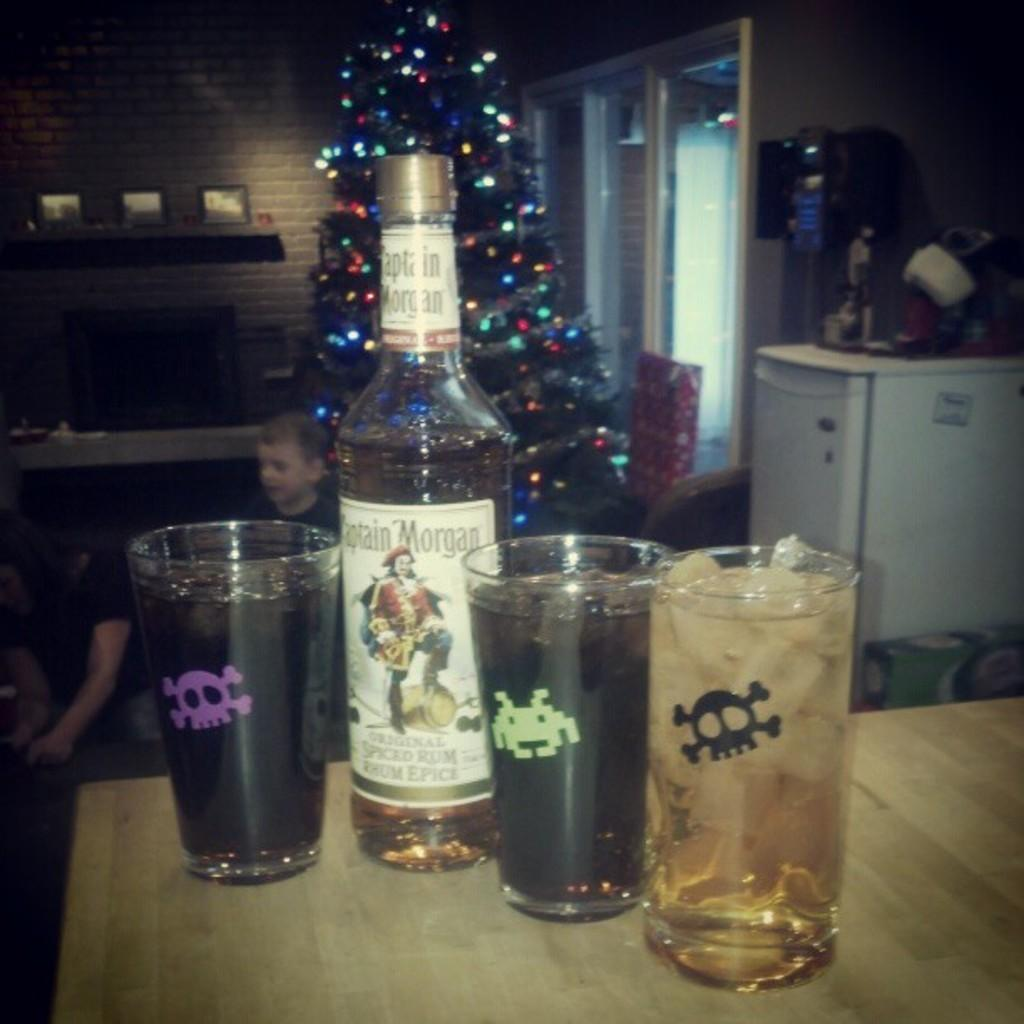<image>
Summarize the visual content of the image. Captain Morgan Rum drink with 3 glasses of Rum with different labels on them. 